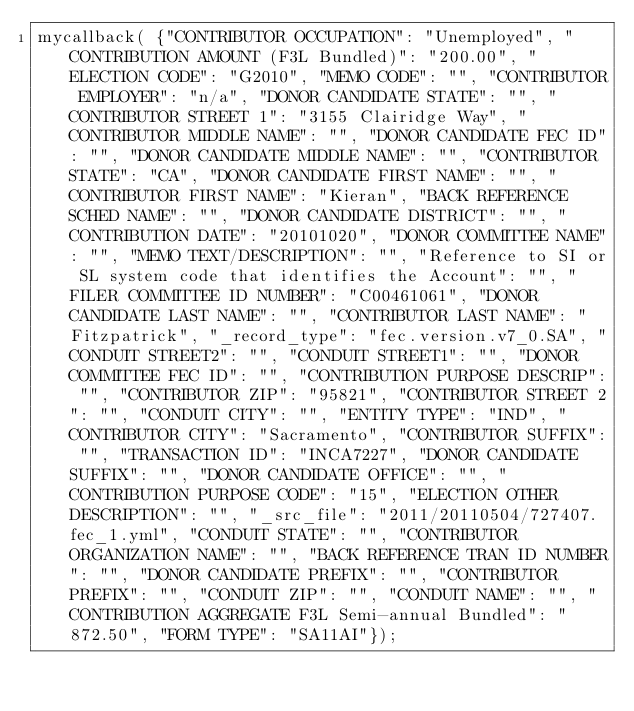Convert code to text. <code><loc_0><loc_0><loc_500><loc_500><_JavaScript_>mycallback( {"CONTRIBUTOR OCCUPATION": "Unemployed", "CONTRIBUTION AMOUNT (F3L Bundled)": "200.00", "ELECTION CODE": "G2010", "MEMO CODE": "", "CONTRIBUTOR EMPLOYER": "n/a", "DONOR CANDIDATE STATE": "", "CONTRIBUTOR STREET 1": "3155 Clairidge Way", "CONTRIBUTOR MIDDLE NAME": "", "DONOR CANDIDATE FEC ID": "", "DONOR CANDIDATE MIDDLE NAME": "", "CONTRIBUTOR STATE": "CA", "DONOR CANDIDATE FIRST NAME": "", "CONTRIBUTOR FIRST NAME": "Kieran", "BACK REFERENCE SCHED NAME": "", "DONOR CANDIDATE DISTRICT": "", "CONTRIBUTION DATE": "20101020", "DONOR COMMITTEE NAME": "", "MEMO TEXT/DESCRIPTION": "", "Reference to SI or SL system code that identifies the Account": "", "FILER COMMITTEE ID NUMBER": "C00461061", "DONOR CANDIDATE LAST NAME": "", "CONTRIBUTOR LAST NAME": "Fitzpatrick", "_record_type": "fec.version.v7_0.SA", "CONDUIT STREET2": "", "CONDUIT STREET1": "", "DONOR COMMITTEE FEC ID": "", "CONTRIBUTION PURPOSE DESCRIP": "", "CONTRIBUTOR ZIP": "95821", "CONTRIBUTOR STREET 2": "", "CONDUIT CITY": "", "ENTITY TYPE": "IND", "CONTRIBUTOR CITY": "Sacramento", "CONTRIBUTOR SUFFIX": "", "TRANSACTION ID": "INCA7227", "DONOR CANDIDATE SUFFIX": "", "DONOR CANDIDATE OFFICE": "", "CONTRIBUTION PURPOSE CODE": "15", "ELECTION OTHER DESCRIPTION": "", "_src_file": "2011/20110504/727407.fec_1.yml", "CONDUIT STATE": "", "CONTRIBUTOR ORGANIZATION NAME": "", "BACK REFERENCE TRAN ID NUMBER": "", "DONOR CANDIDATE PREFIX": "", "CONTRIBUTOR PREFIX": "", "CONDUIT ZIP": "", "CONDUIT NAME": "", "CONTRIBUTION AGGREGATE F3L Semi-annual Bundled": "872.50", "FORM TYPE": "SA11AI"});
</code> 